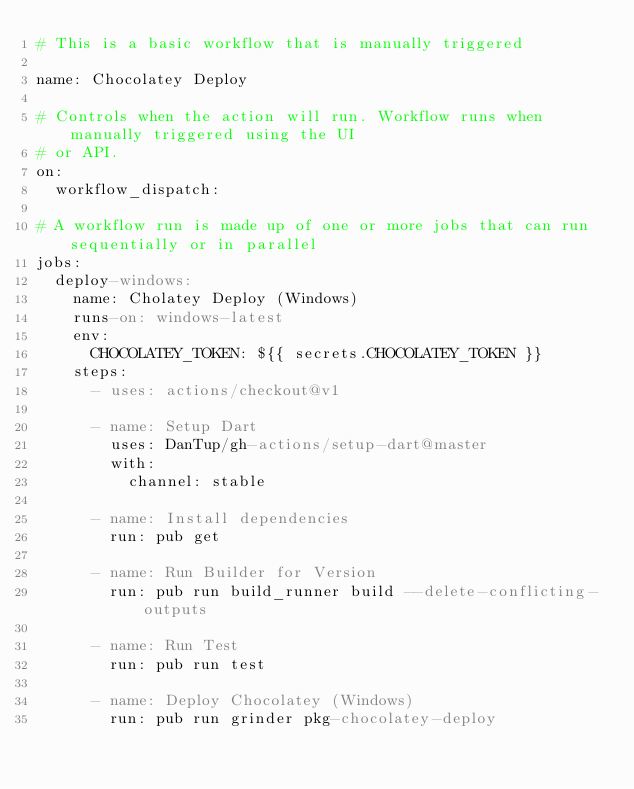<code> <loc_0><loc_0><loc_500><loc_500><_YAML_># This is a basic workflow that is manually triggered

name: Chocolatey Deploy

# Controls when the action will run. Workflow runs when manually triggered using the UI
# or API.
on:
  workflow_dispatch:

# A workflow run is made up of one or more jobs that can run sequentially or in parallel
jobs:
  deploy-windows:
    name: Cholatey Deploy (Windows)
    runs-on: windows-latest
    env:
      CHOCOLATEY_TOKEN: ${{ secrets.CHOCOLATEY_TOKEN }}
    steps:
      - uses: actions/checkout@v1

      - name: Setup Dart
        uses: DanTup/gh-actions/setup-dart@master
        with:
          channel: stable

      - name: Install dependencies
        run: pub get

      - name: Run Builder for Version
        run: pub run build_runner build --delete-conflicting-outputs

      - name: Run Test
        run: pub run test

      - name: Deploy Chocolatey (Windows)
        run: pub run grinder pkg-chocolatey-deploy
</code> 